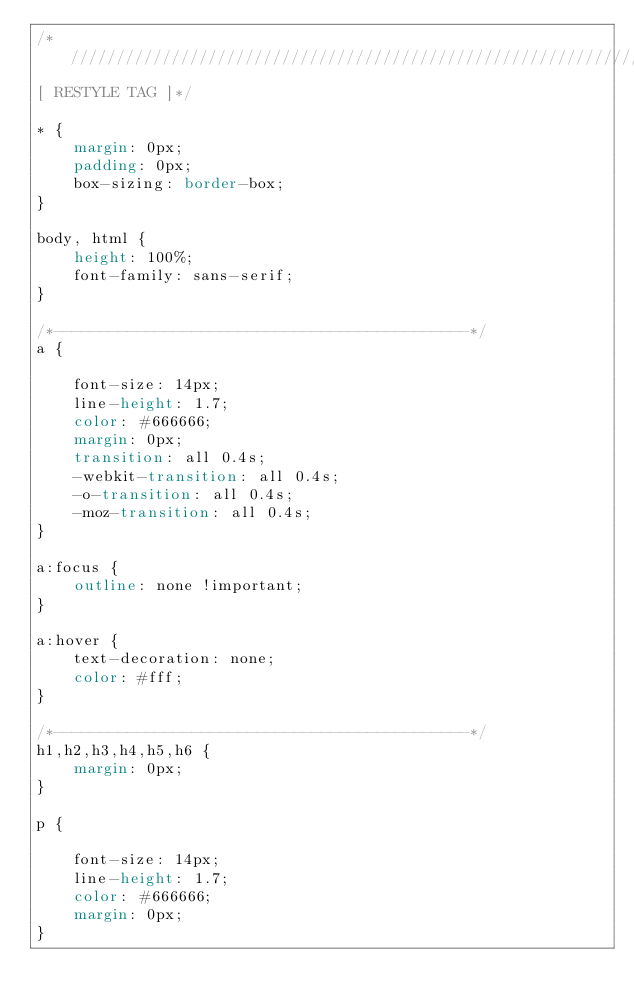<code> <loc_0><loc_0><loc_500><loc_500><_CSS_>/*//////////////////////////////////////////////////////////////////
[ RESTYLE TAG ]*/

* {
    margin: 0px;
    padding: 0px;
    box-sizing: border-box;
}

body, html {
    height: 100%;
    font-family: sans-serif;
}

/*---------------------------------------------*/
a {
    
    font-size: 14px;
    line-height: 1.7;
    color: #666666;
    margin: 0px;
    transition: all 0.4s;
    -webkit-transition: all 0.4s;
    -o-transition: all 0.4s;
    -moz-transition: all 0.4s;
}

a:focus {
    outline: none !important;
}

a:hover {
    text-decoration: none;
    color: #fff;
}

/*---------------------------------------------*/
h1,h2,h3,h4,h5,h6 {
    margin: 0px;
}

p {
    
    font-size: 14px;
    line-height: 1.7;
    color: #666666;
    margin: 0px;
}
</code> 